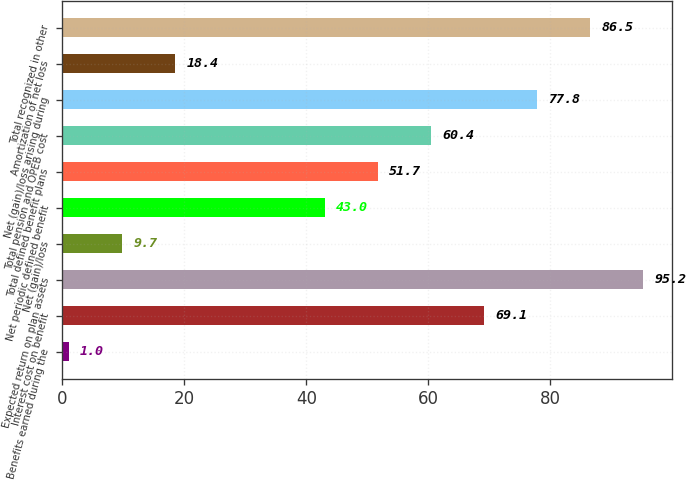Convert chart to OTSL. <chart><loc_0><loc_0><loc_500><loc_500><bar_chart><fcel>Benefits earned during the<fcel>Interest cost on benefit<fcel>Expected return on plan assets<fcel>Net (gain)/loss<fcel>Net periodic defined benefit<fcel>Total defined benefit plans<fcel>Total pension and OPEB cost<fcel>Net (gain)/loss arising during<fcel>Amortization of net loss<fcel>Total recognized in other<nl><fcel>1<fcel>69.1<fcel>95.2<fcel>9.7<fcel>43<fcel>51.7<fcel>60.4<fcel>77.8<fcel>18.4<fcel>86.5<nl></chart> 